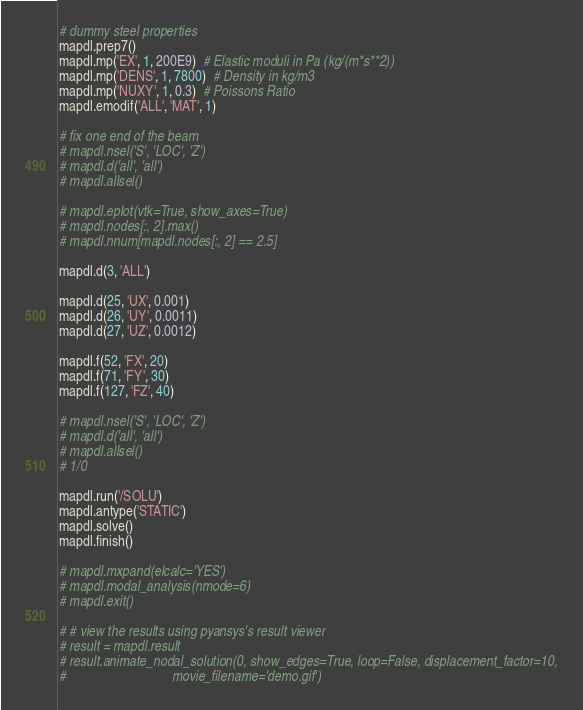<code> <loc_0><loc_0><loc_500><loc_500><_Python_># dummy steel properties
mapdl.prep7()
mapdl.mp('EX', 1, 200E9)  # Elastic moduli in Pa (kg/(m*s**2))
mapdl.mp('DENS', 1, 7800)  # Density in kg/m3
mapdl.mp('NUXY', 1, 0.3)  # Poissons Ratio
mapdl.emodif('ALL', 'MAT', 1)

# fix one end of the beam
# mapdl.nsel('S', 'LOC', 'Z')
# mapdl.d('all', 'all')
# mapdl.allsel()

# mapdl.eplot(vtk=True, show_axes=True)
# mapdl.nodes[:, 2].max()
# mapdl.nnum[mapdl.nodes[:, 2] == 2.5]

mapdl.d(3, 'ALL')

mapdl.d(25, 'UX', 0.001)
mapdl.d(26, 'UY', 0.0011)
mapdl.d(27, 'UZ', 0.0012)

mapdl.f(52, 'FX', 20)
mapdl.f(71, 'FY', 30)
mapdl.f(127, 'FZ', 40)

# mapdl.nsel('S', 'LOC', 'Z')
# mapdl.d('all', 'all')
# mapdl.allsel()
# 1/0

mapdl.run('/SOLU')
mapdl.antype('STATIC')
mapdl.solve()
mapdl.finish()

# mapdl.mxpand(elcalc='YES')
# mapdl.modal_analysis(nmode=6)
# mapdl.exit()

# # view the results using pyansys's result viewer
# result = mapdl.result
# result.animate_nodal_solution(0, show_edges=True, loop=False, displacement_factor=10,
#                               movie_filename='demo.gif')
</code> 